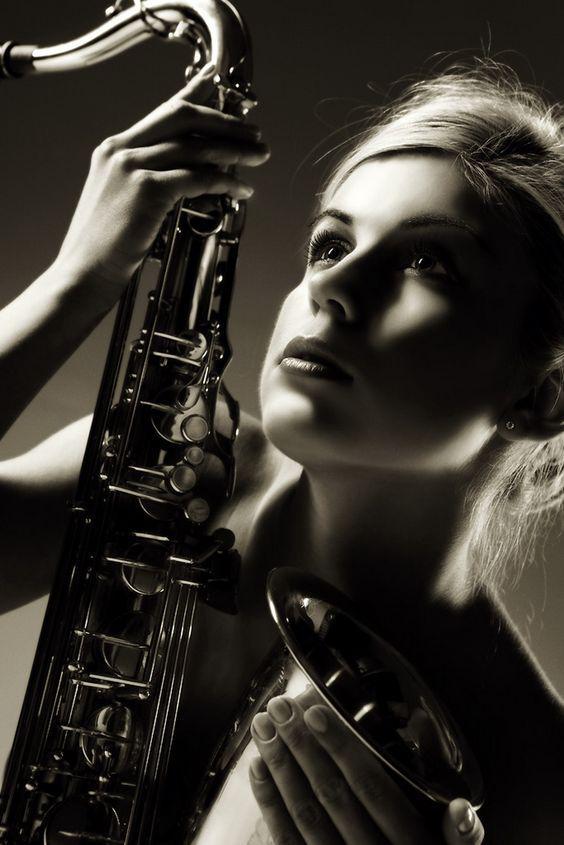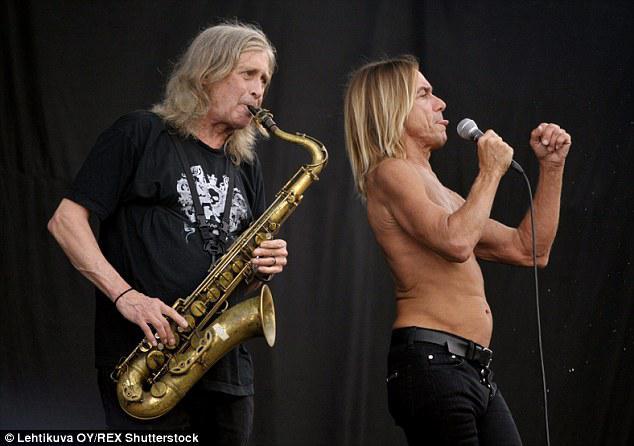The first image is the image on the left, the second image is the image on the right. Analyze the images presented: Is the assertion "The saxophone in each of the images is being played by a female child." valid? Answer yes or no. No. The first image is the image on the left, the second image is the image on the right. Analyze the images presented: Is the assertion "Each image shows a female child holding a saxophone." valid? Answer yes or no. No. 